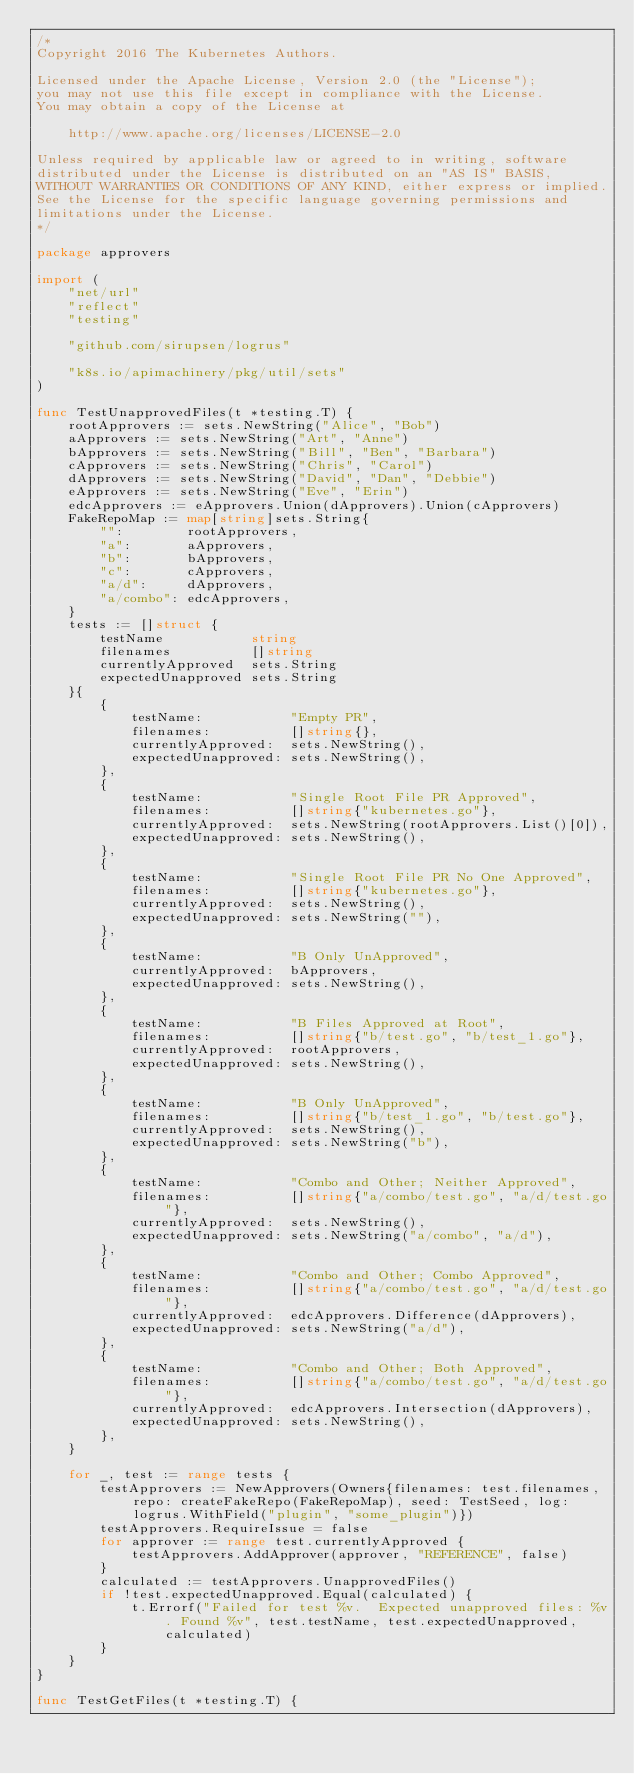<code> <loc_0><loc_0><loc_500><loc_500><_Go_>/*
Copyright 2016 The Kubernetes Authors.

Licensed under the Apache License, Version 2.0 (the "License");
you may not use this file except in compliance with the License.
You may obtain a copy of the License at

    http://www.apache.org/licenses/LICENSE-2.0

Unless required by applicable law or agreed to in writing, software
distributed under the License is distributed on an "AS IS" BASIS,
WITHOUT WARRANTIES OR CONDITIONS OF ANY KIND, either express or implied.
See the License for the specific language governing permissions and
limitations under the License.
*/

package approvers

import (
	"net/url"
	"reflect"
	"testing"

	"github.com/sirupsen/logrus"

	"k8s.io/apimachinery/pkg/util/sets"
)

func TestUnapprovedFiles(t *testing.T) {
	rootApprovers := sets.NewString("Alice", "Bob")
	aApprovers := sets.NewString("Art", "Anne")
	bApprovers := sets.NewString("Bill", "Ben", "Barbara")
	cApprovers := sets.NewString("Chris", "Carol")
	dApprovers := sets.NewString("David", "Dan", "Debbie")
	eApprovers := sets.NewString("Eve", "Erin")
	edcApprovers := eApprovers.Union(dApprovers).Union(cApprovers)
	FakeRepoMap := map[string]sets.String{
		"":        rootApprovers,
		"a":       aApprovers,
		"b":       bApprovers,
		"c":       cApprovers,
		"a/d":     dApprovers,
		"a/combo": edcApprovers,
	}
	tests := []struct {
		testName           string
		filenames          []string
		currentlyApproved  sets.String
		expectedUnapproved sets.String
	}{
		{
			testName:           "Empty PR",
			filenames:          []string{},
			currentlyApproved:  sets.NewString(),
			expectedUnapproved: sets.NewString(),
		},
		{
			testName:           "Single Root File PR Approved",
			filenames:          []string{"kubernetes.go"},
			currentlyApproved:  sets.NewString(rootApprovers.List()[0]),
			expectedUnapproved: sets.NewString(),
		},
		{
			testName:           "Single Root File PR No One Approved",
			filenames:          []string{"kubernetes.go"},
			currentlyApproved:  sets.NewString(),
			expectedUnapproved: sets.NewString(""),
		},
		{
			testName:           "B Only UnApproved",
			currentlyApproved:  bApprovers,
			expectedUnapproved: sets.NewString(),
		},
		{
			testName:           "B Files Approved at Root",
			filenames:          []string{"b/test.go", "b/test_1.go"},
			currentlyApproved:  rootApprovers,
			expectedUnapproved: sets.NewString(),
		},
		{
			testName:           "B Only UnApproved",
			filenames:          []string{"b/test_1.go", "b/test.go"},
			currentlyApproved:  sets.NewString(),
			expectedUnapproved: sets.NewString("b"),
		},
		{
			testName:           "Combo and Other; Neither Approved",
			filenames:          []string{"a/combo/test.go", "a/d/test.go"},
			currentlyApproved:  sets.NewString(),
			expectedUnapproved: sets.NewString("a/combo", "a/d"),
		},
		{
			testName:           "Combo and Other; Combo Approved",
			filenames:          []string{"a/combo/test.go", "a/d/test.go"},
			currentlyApproved:  edcApprovers.Difference(dApprovers),
			expectedUnapproved: sets.NewString("a/d"),
		},
		{
			testName:           "Combo and Other; Both Approved",
			filenames:          []string{"a/combo/test.go", "a/d/test.go"},
			currentlyApproved:  edcApprovers.Intersection(dApprovers),
			expectedUnapproved: sets.NewString(),
		},
	}

	for _, test := range tests {
		testApprovers := NewApprovers(Owners{filenames: test.filenames, repo: createFakeRepo(FakeRepoMap), seed: TestSeed, log: logrus.WithField("plugin", "some_plugin")})
		testApprovers.RequireIssue = false
		for approver := range test.currentlyApproved {
			testApprovers.AddApprover(approver, "REFERENCE", false)
		}
		calculated := testApprovers.UnapprovedFiles()
		if !test.expectedUnapproved.Equal(calculated) {
			t.Errorf("Failed for test %v.  Expected unapproved files: %v. Found %v", test.testName, test.expectedUnapproved, calculated)
		}
	}
}

func TestGetFiles(t *testing.T) {</code> 